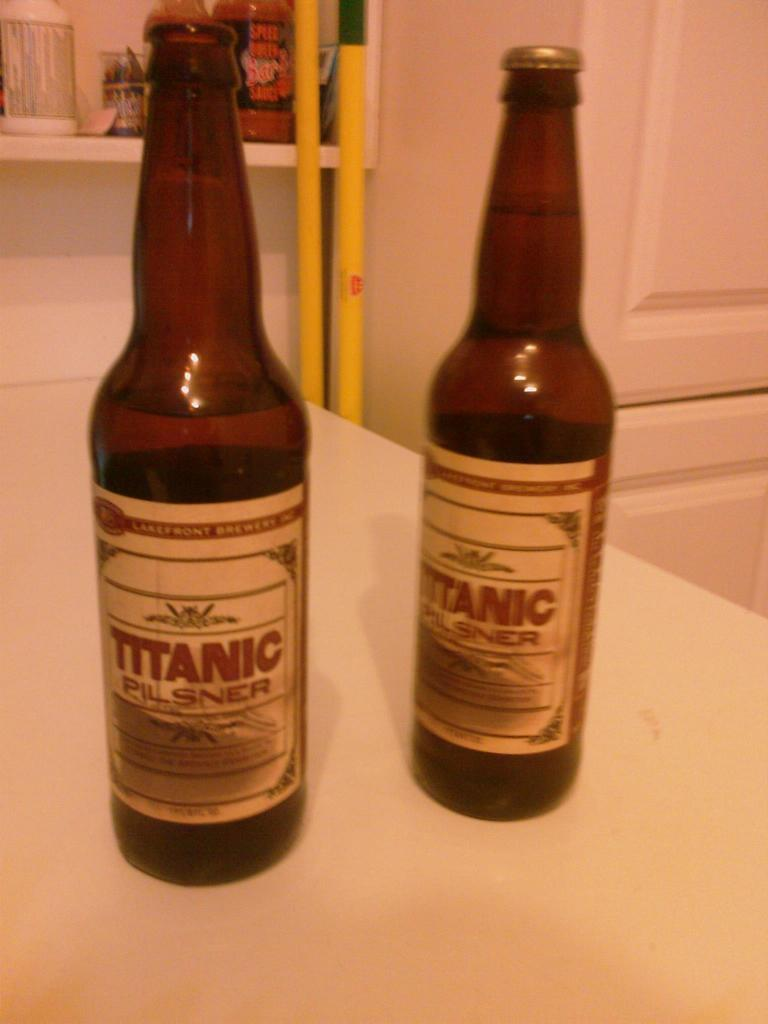<image>
Render a clear and concise summary of the photo. Two bottles of beer with the words Titanic Pilsner on them 